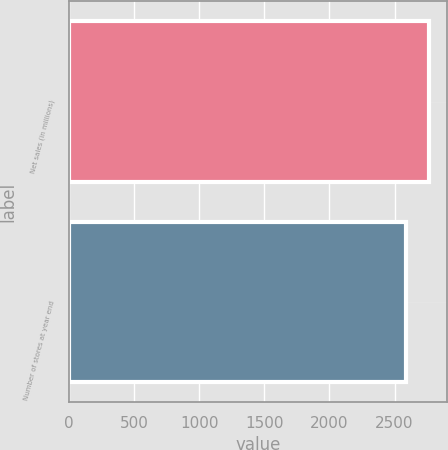Convert chart. <chart><loc_0><loc_0><loc_500><loc_500><bar_chart><fcel>Net sales (in millions)<fcel>Number of stores at year end<nl><fcel>2766.9<fcel>2585<nl></chart> 